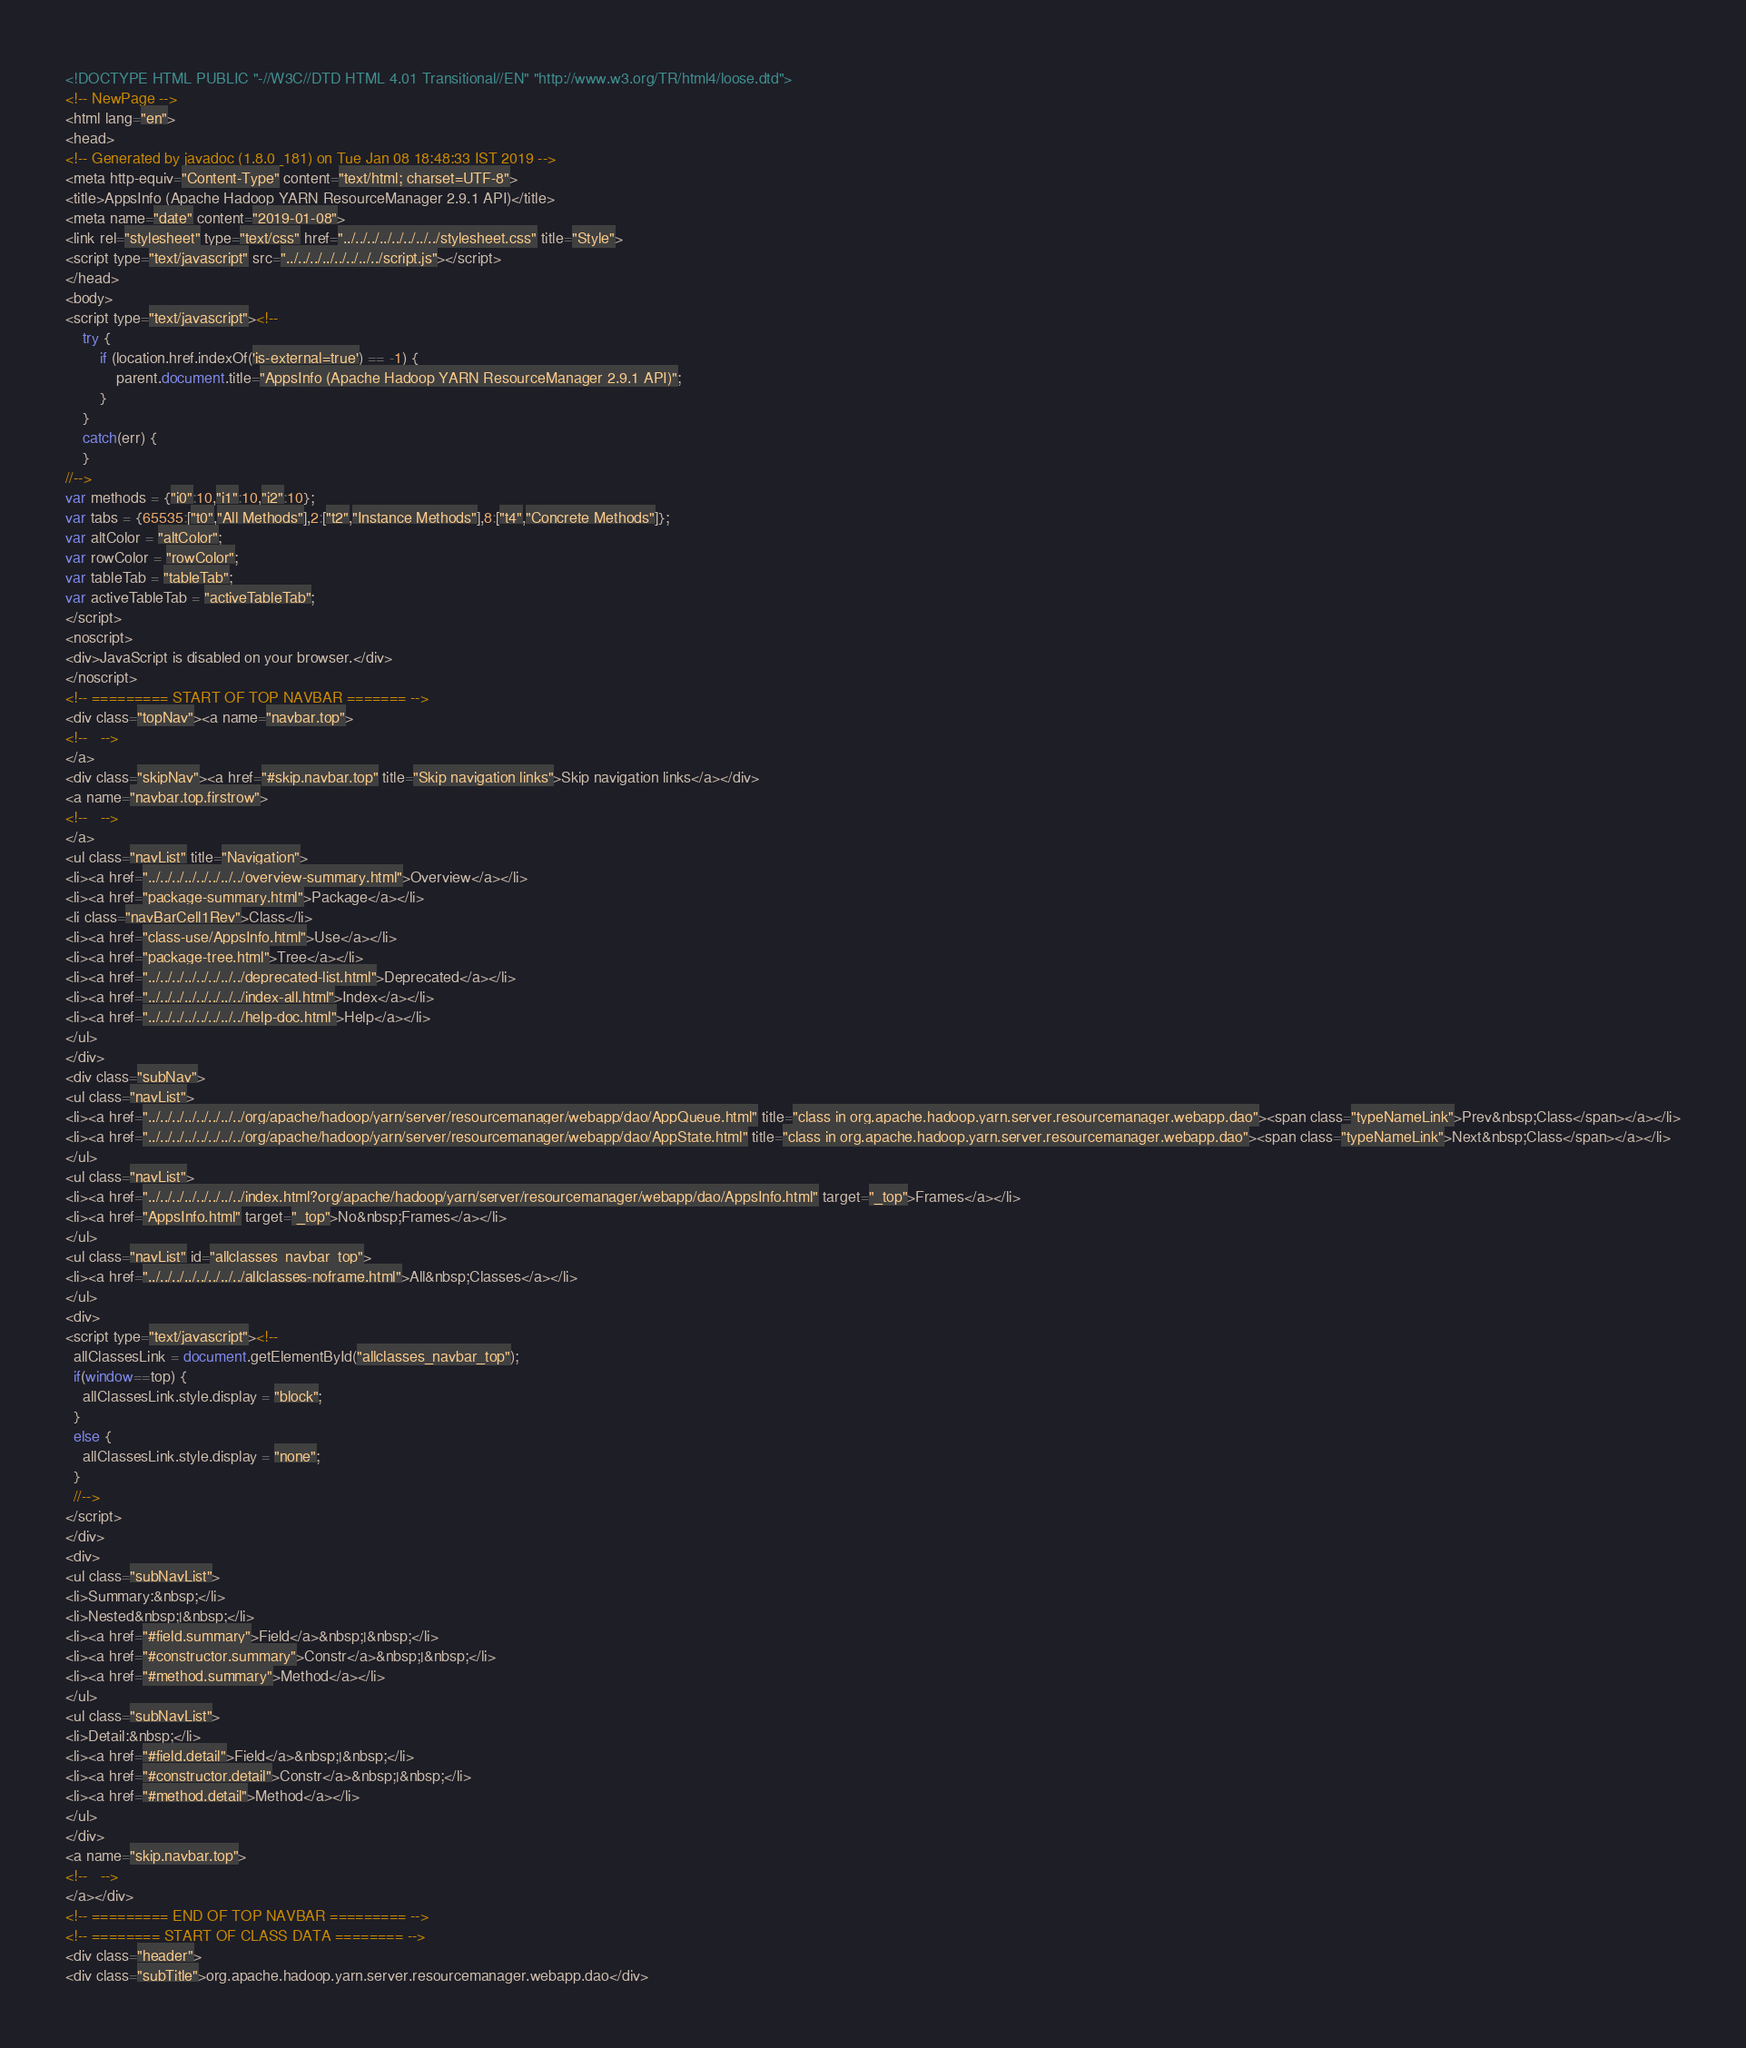<code> <loc_0><loc_0><loc_500><loc_500><_HTML_><!DOCTYPE HTML PUBLIC "-//W3C//DTD HTML 4.01 Transitional//EN" "http://www.w3.org/TR/html4/loose.dtd">
<!-- NewPage -->
<html lang="en">
<head>
<!-- Generated by javadoc (1.8.0_181) on Tue Jan 08 18:48:33 IST 2019 -->
<meta http-equiv="Content-Type" content="text/html; charset=UTF-8">
<title>AppsInfo (Apache Hadoop YARN ResourceManager 2.9.1 API)</title>
<meta name="date" content="2019-01-08">
<link rel="stylesheet" type="text/css" href="../../../../../../../../stylesheet.css" title="Style">
<script type="text/javascript" src="../../../../../../../../script.js"></script>
</head>
<body>
<script type="text/javascript"><!--
    try {
        if (location.href.indexOf('is-external=true') == -1) {
            parent.document.title="AppsInfo (Apache Hadoop YARN ResourceManager 2.9.1 API)";
        }
    }
    catch(err) {
    }
//-->
var methods = {"i0":10,"i1":10,"i2":10};
var tabs = {65535:["t0","All Methods"],2:["t2","Instance Methods"],8:["t4","Concrete Methods"]};
var altColor = "altColor";
var rowColor = "rowColor";
var tableTab = "tableTab";
var activeTableTab = "activeTableTab";
</script>
<noscript>
<div>JavaScript is disabled on your browser.</div>
</noscript>
<!-- ========= START OF TOP NAVBAR ======= -->
<div class="topNav"><a name="navbar.top">
<!--   -->
</a>
<div class="skipNav"><a href="#skip.navbar.top" title="Skip navigation links">Skip navigation links</a></div>
<a name="navbar.top.firstrow">
<!--   -->
</a>
<ul class="navList" title="Navigation">
<li><a href="../../../../../../../../overview-summary.html">Overview</a></li>
<li><a href="package-summary.html">Package</a></li>
<li class="navBarCell1Rev">Class</li>
<li><a href="class-use/AppsInfo.html">Use</a></li>
<li><a href="package-tree.html">Tree</a></li>
<li><a href="../../../../../../../../deprecated-list.html">Deprecated</a></li>
<li><a href="../../../../../../../../index-all.html">Index</a></li>
<li><a href="../../../../../../../../help-doc.html">Help</a></li>
</ul>
</div>
<div class="subNav">
<ul class="navList">
<li><a href="../../../../../../../../org/apache/hadoop/yarn/server/resourcemanager/webapp/dao/AppQueue.html" title="class in org.apache.hadoop.yarn.server.resourcemanager.webapp.dao"><span class="typeNameLink">Prev&nbsp;Class</span></a></li>
<li><a href="../../../../../../../../org/apache/hadoop/yarn/server/resourcemanager/webapp/dao/AppState.html" title="class in org.apache.hadoop.yarn.server.resourcemanager.webapp.dao"><span class="typeNameLink">Next&nbsp;Class</span></a></li>
</ul>
<ul class="navList">
<li><a href="../../../../../../../../index.html?org/apache/hadoop/yarn/server/resourcemanager/webapp/dao/AppsInfo.html" target="_top">Frames</a></li>
<li><a href="AppsInfo.html" target="_top">No&nbsp;Frames</a></li>
</ul>
<ul class="navList" id="allclasses_navbar_top">
<li><a href="../../../../../../../../allclasses-noframe.html">All&nbsp;Classes</a></li>
</ul>
<div>
<script type="text/javascript"><!--
  allClassesLink = document.getElementById("allclasses_navbar_top");
  if(window==top) {
    allClassesLink.style.display = "block";
  }
  else {
    allClassesLink.style.display = "none";
  }
  //-->
</script>
</div>
<div>
<ul class="subNavList">
<li>Summary:&nbsp;</li>
<li>Nested&nbsp;|&nbsp;</li>
<li><a href="#field.summary">Field</a>&nbsp;|&nbsp;</li>
<li><a href="#constructor.summary">Constr</a>&nbsp;|&nbsp;</li>
<li><a href="#method.summary">Method</a></li>
</ul>
<ul class="subNavList">
<li>Detail:&nbsp;</li>
<li><a href="#field.detail">Field</a>&nbsp;|&nbsp;</li>
<li><a href="#constructor.detail">Constr</a>&nbsp;|&nbsp;</li>
<li><a href="#method.detail">Method</a></li>
</ul>
</div>
<a name="skip.navbar.top">
<!--   -->
</a></div>
<!-- ========= END OF TOP NAVBAR ========= -->
<!-- ======== START OF CLASS DATA ======== -->
<div class="header">
<div class="subTitle">org.apache.hadoop.yarn.server.resourcemanager.webapp.dao</div></code> 